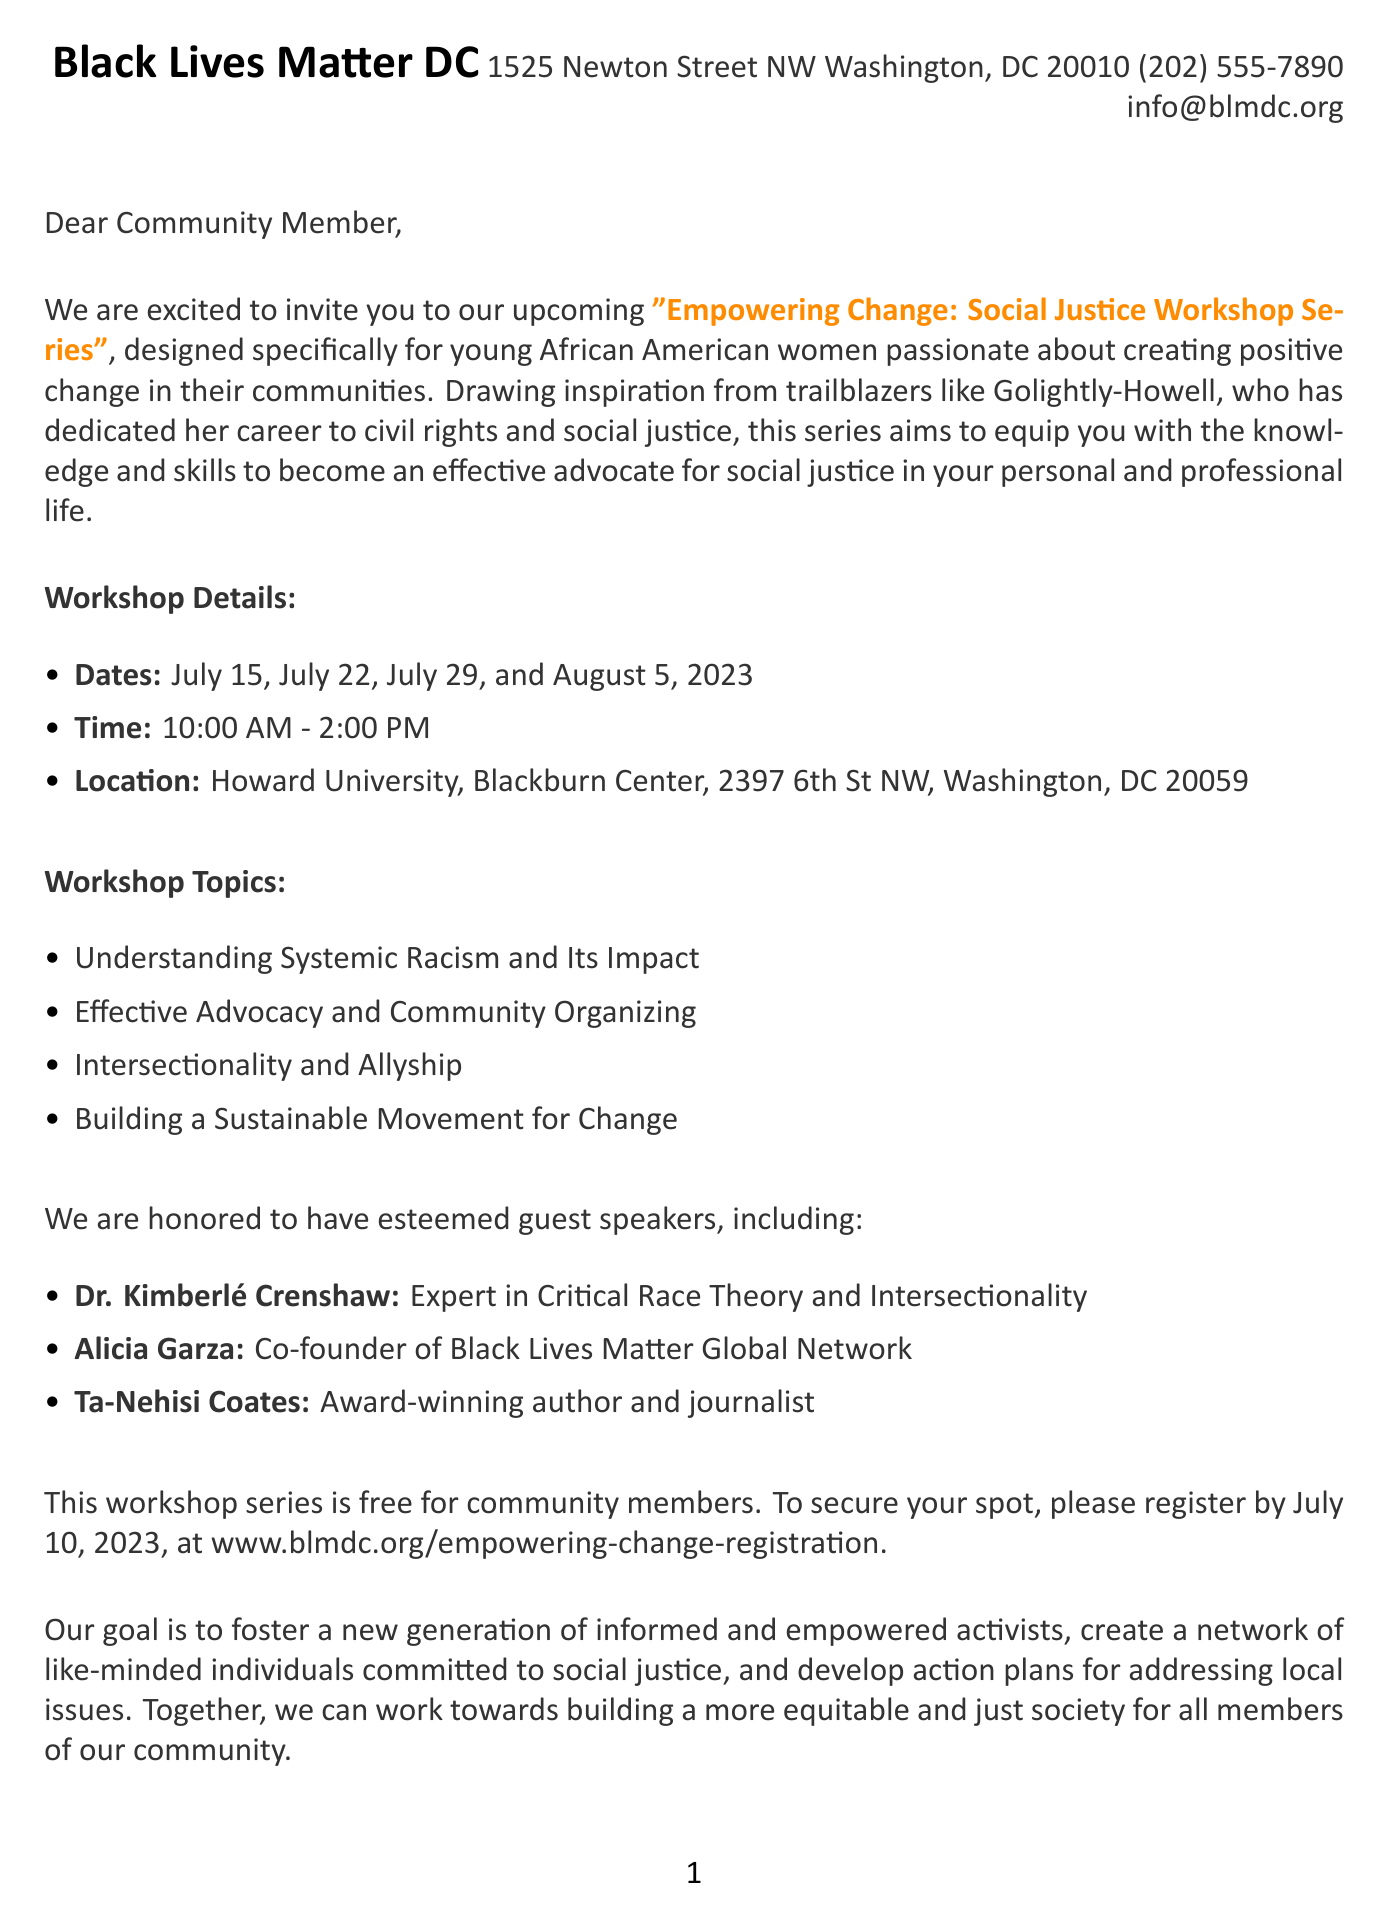What is the name of the organization hosting the workshop? The name of the organization is specified in the document as Black Lives Matter DC.
Answer: Black Lives Matter DC What is the deadline for registration? The registration deadline is explicitly stated in the document as July 10, 2023.
Answer: July 10, 2023 Who is one of the guest speakers for the workshop? The document lists multiple guest speakers, one of whom is Dr. Kimberlé Crenshaw.
Answer: Dr. Kimberlé Crenshaw What is the time duration of the workshops? The workshops are scheduled from 10:00 AM to 2:00 PM as stated in the document.
Answer: 10:00 AM - 2:00 PM What is the main goal of the workshop series? The document outlines the goal to foster a new generation of informed and empowered activists.
Answer: Foster a new generation of informed and empowered activists How many dates are included in the workshop series? The document lists four specific dates for the workshops, providing a count.
Answer: Four What is the location of the workshops? The workshops will be held at Howard University, Blackburn Center, as mentioned in the document.
Answer: Howard University, Blackburn Center What type of participants is the workshop targeting? The document specifies the target audience as young African American women.
Answer: Young African American women What format do the additional resources take? The document describes the additional resources as a reading list and online platforms.
Answer: Reading list and online platforms 